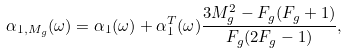<formula> <loc_0><loc_0><loc_500><loc_500>\alpha _ { 1 , M _ { g } } ( \omega ) = \alpha _ { 1 } ( \omega ) + \alpha ^ { T } _ { 1 } ( \omega ) \frac { 3 M _ { g } ^ { 2 } - F _ { g } ( F _ { g } + 1 ) } { F _ { g } ( 2 F _ { g } - 1 ) } ,</formula> 